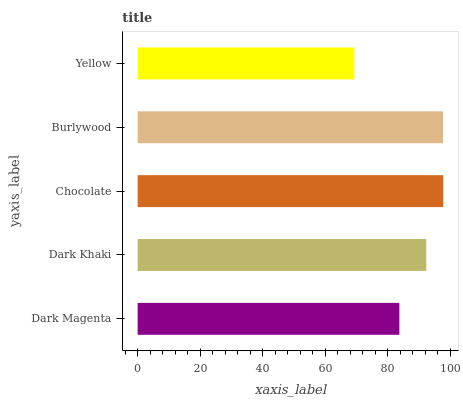Is Yellow the minimum?
Answer yes or no. Yes. Is Chocolate the maximum?
Answer yes or no. Yes. Is Dark Khaki the minimum?
Answer yes or no. No. Is Dark Khaki the maximum?
Answer yes or no. No. Is Dark Khaki greater than Dark Magenta?
Answer yes or no. Yes. Is Dark Magenta less than Dark Khaki?
Answer yes or no. Yes. Is Dark Magenta greater than Dark Khaki?
Answer yes or no. No. Is Dark Khaki less than Dark Magenta?
Answer yes or no. No. Is Dark Khaki the high median?
Answer yes or no. Yes. Is Dark Khaki the low median?
Answer yes or no. Yes. Is Yellow the high median?
Answer yes or no. No. Is Yellow the low median?
Answer yes or no. No. 